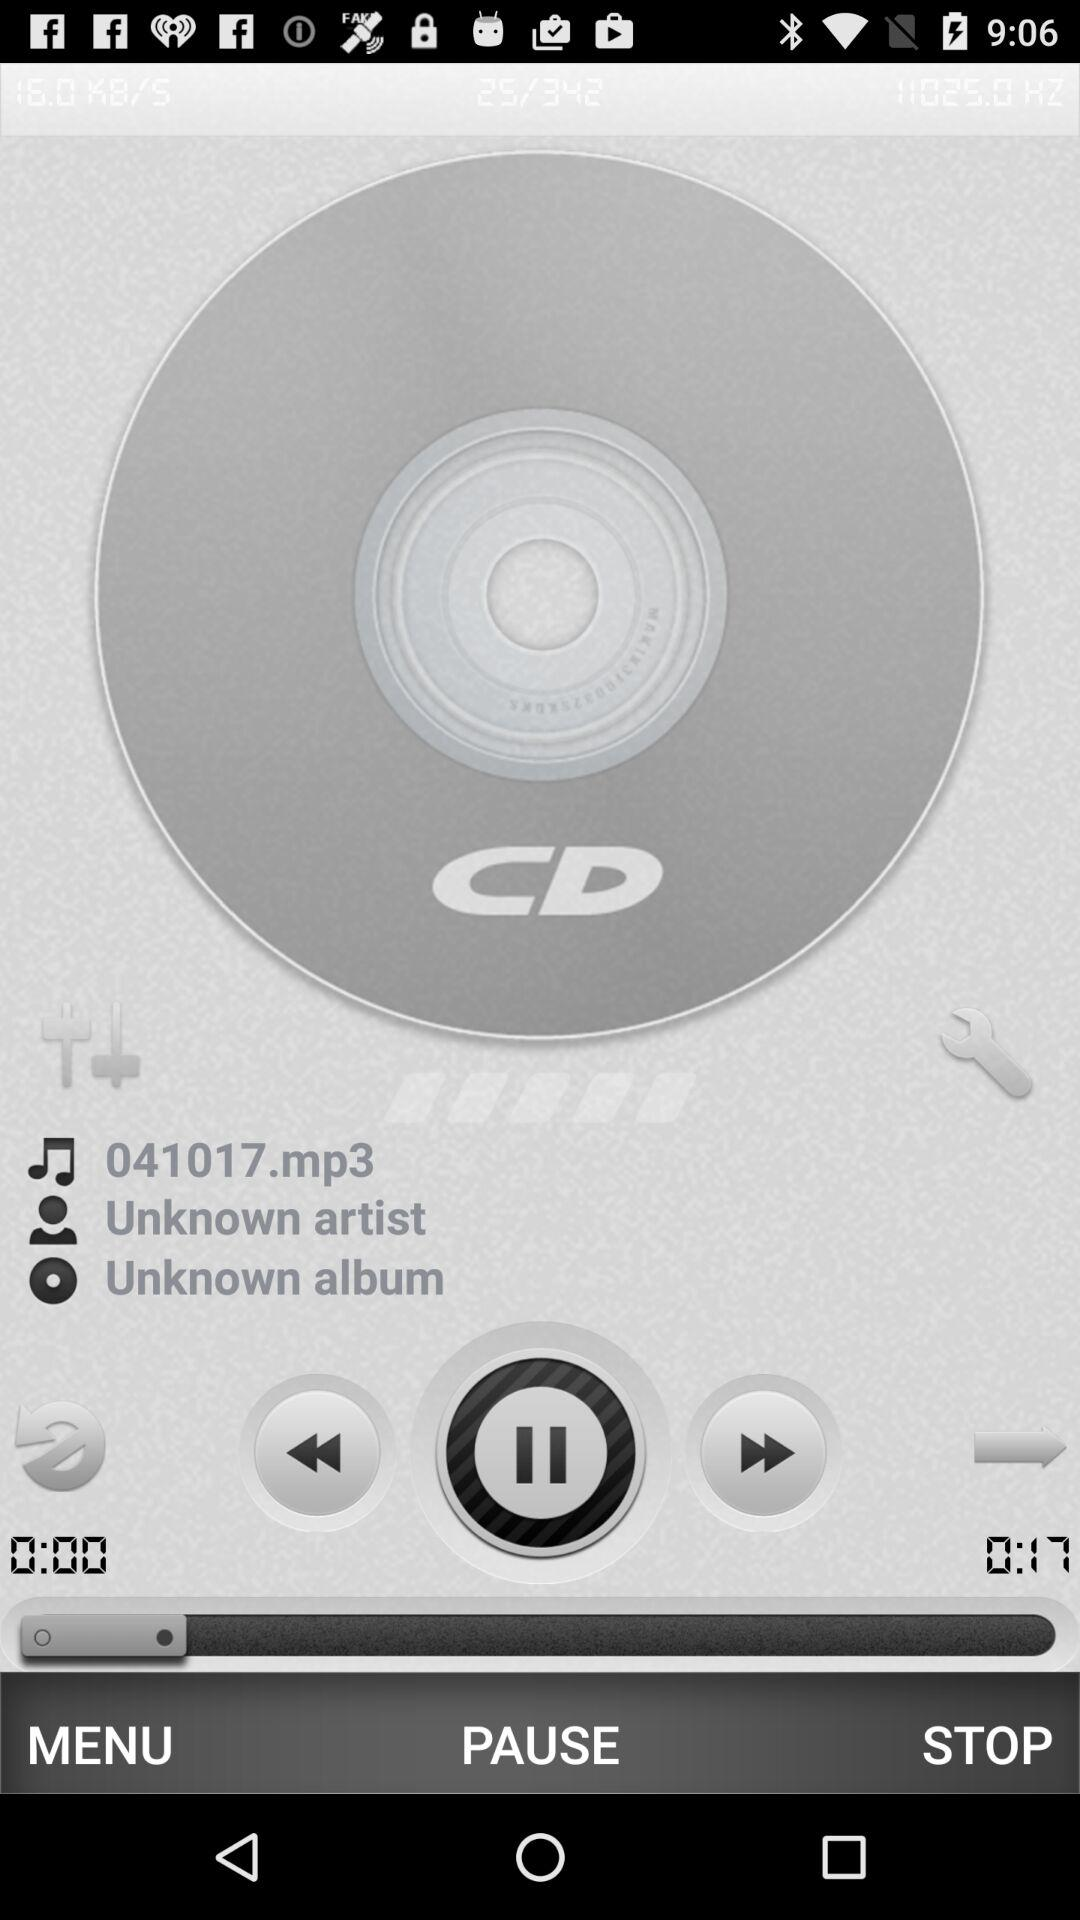What is the duration of the audio? The duration of the audio is 17 seconds. 